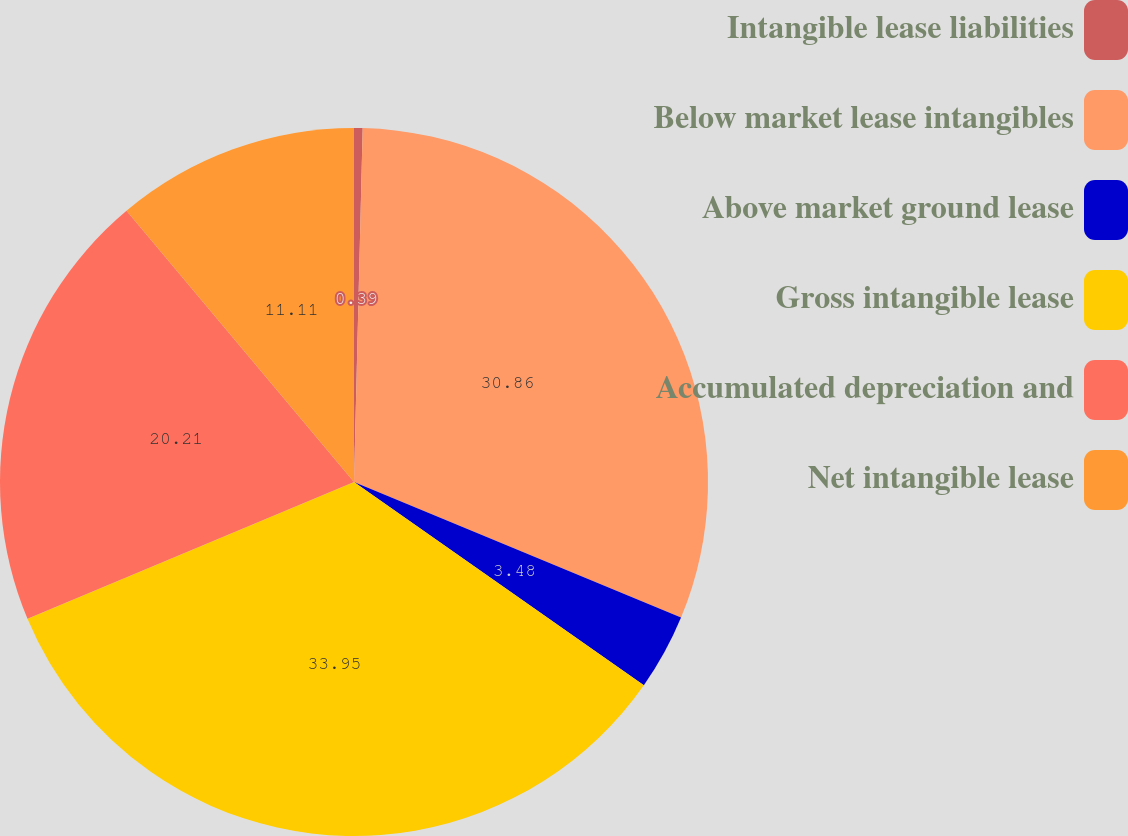Convert chart. <chart><loc_0><loc_0><loc_500><loc_500><pie_chart><fcel>Intangible lease liabilities<fcel>Below market lease intangibles<fcel>Above market ground lease<fcel>Gross intangible lease<fcel>Accumulated depreciation and<fcel>Net intangible lease<nl><fcel>0.39%<fcel>30.87%<fcel>3.48%<fcel>33.96%<fcel>20.21%<fcel>11.11%<nl></chart> 